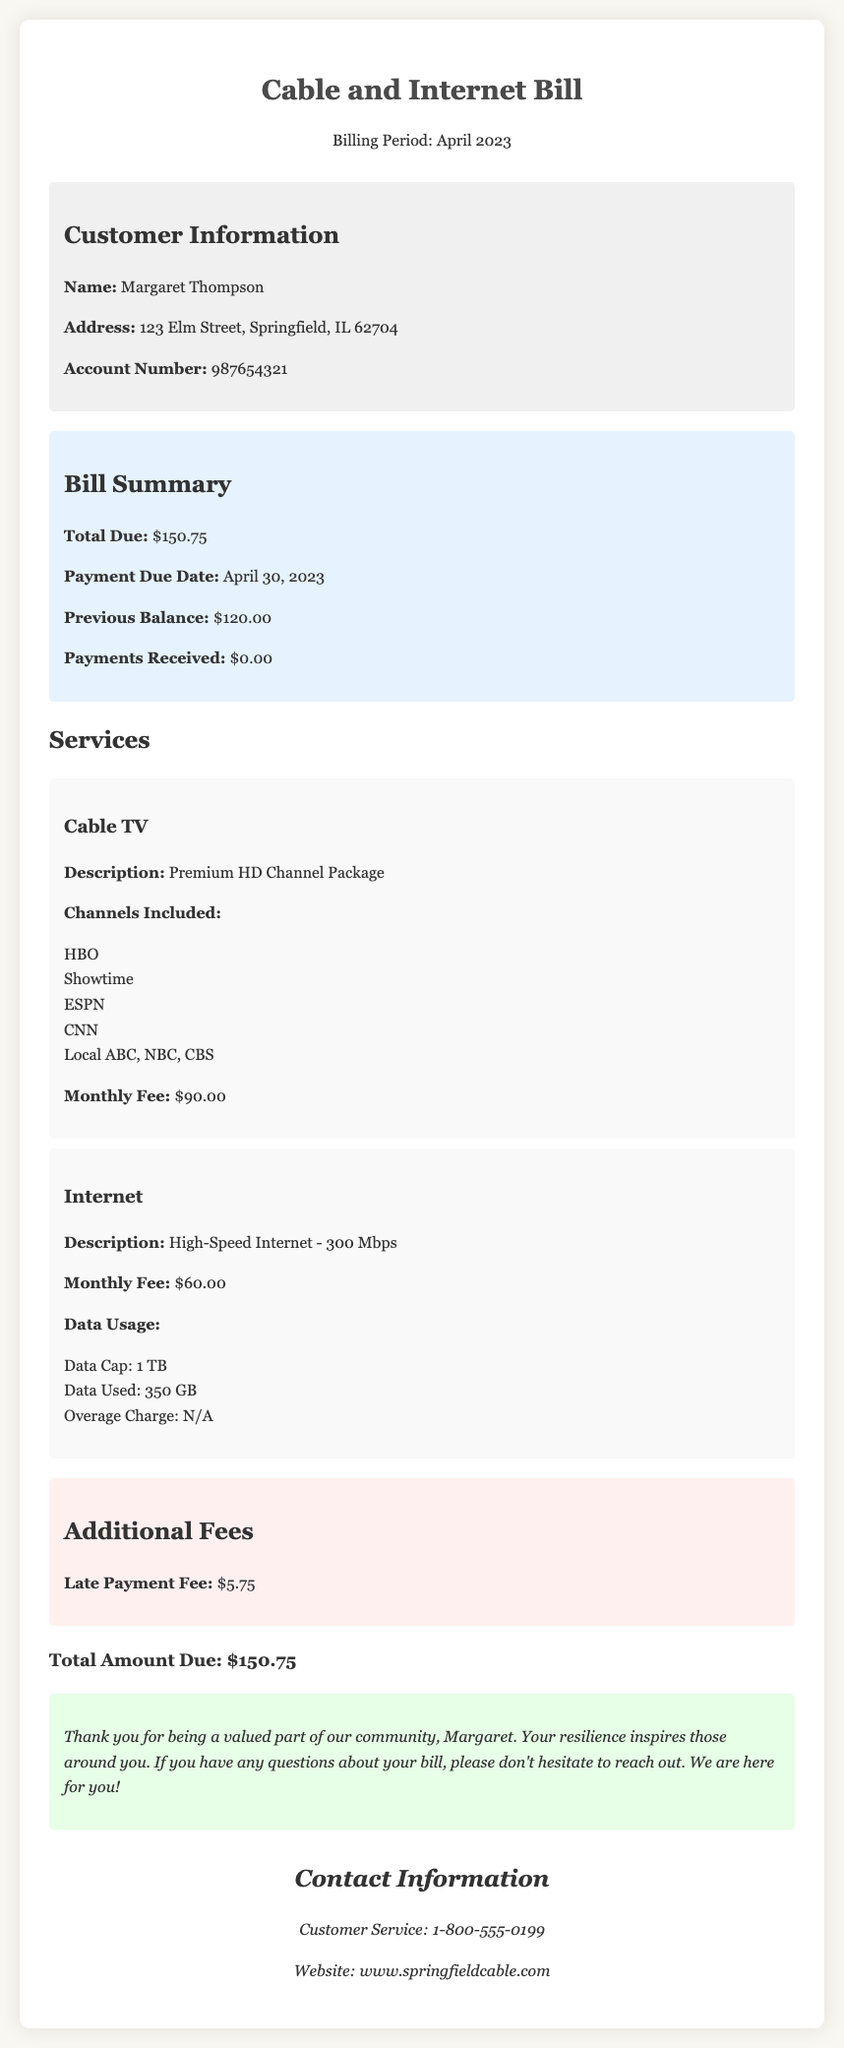What is the customer's name? The customer's name is clearly stated in the customer information section of the document as Margaret Thompson.
Answer: Margaret Thompson What is the total due amount? The total due amount is mentioned in the bill summary section of the document, which states the total as $150.75.
Answer: $150.75 What is the payment due date? The payment due date is indicated in the bill summary section, which specifies the due date as April 30, 2023.
Answer: April 30, 2023 What is the monthly fee for the cable TV service? The monthly fee for the cable TV service is provided in the services section, specifically stating $90.00.
Answer: $90.00 How much data was used for the internet service? The data used for the internet service is mentioned in the services section, indicating that 350 GB was used.
Answer: 350 GB What is the data cap for the internet plan? The document specifies the data cap for the internet plan in the services section, which is 1 TB.
Answer: 1 TB What is the late payment fee? The late payment fee is noted in the additional fees section of the document, which lists it as $5.75.
Answer: $5.75 What type of internet service is provided? The type of internet service is described in the services section, stating that it is high-speed internet of 300 Mbps.
Answer: High-Speed Internet - 300 Mbps Which premium channels are included in the cable package? The included premium channels are detailed in the services section, listing HBO, Showtime, ESPN, CNN, and local channels.
Answer: HBO, Showtime, ESPN, CNN, Local ABC, NBC, CBS 